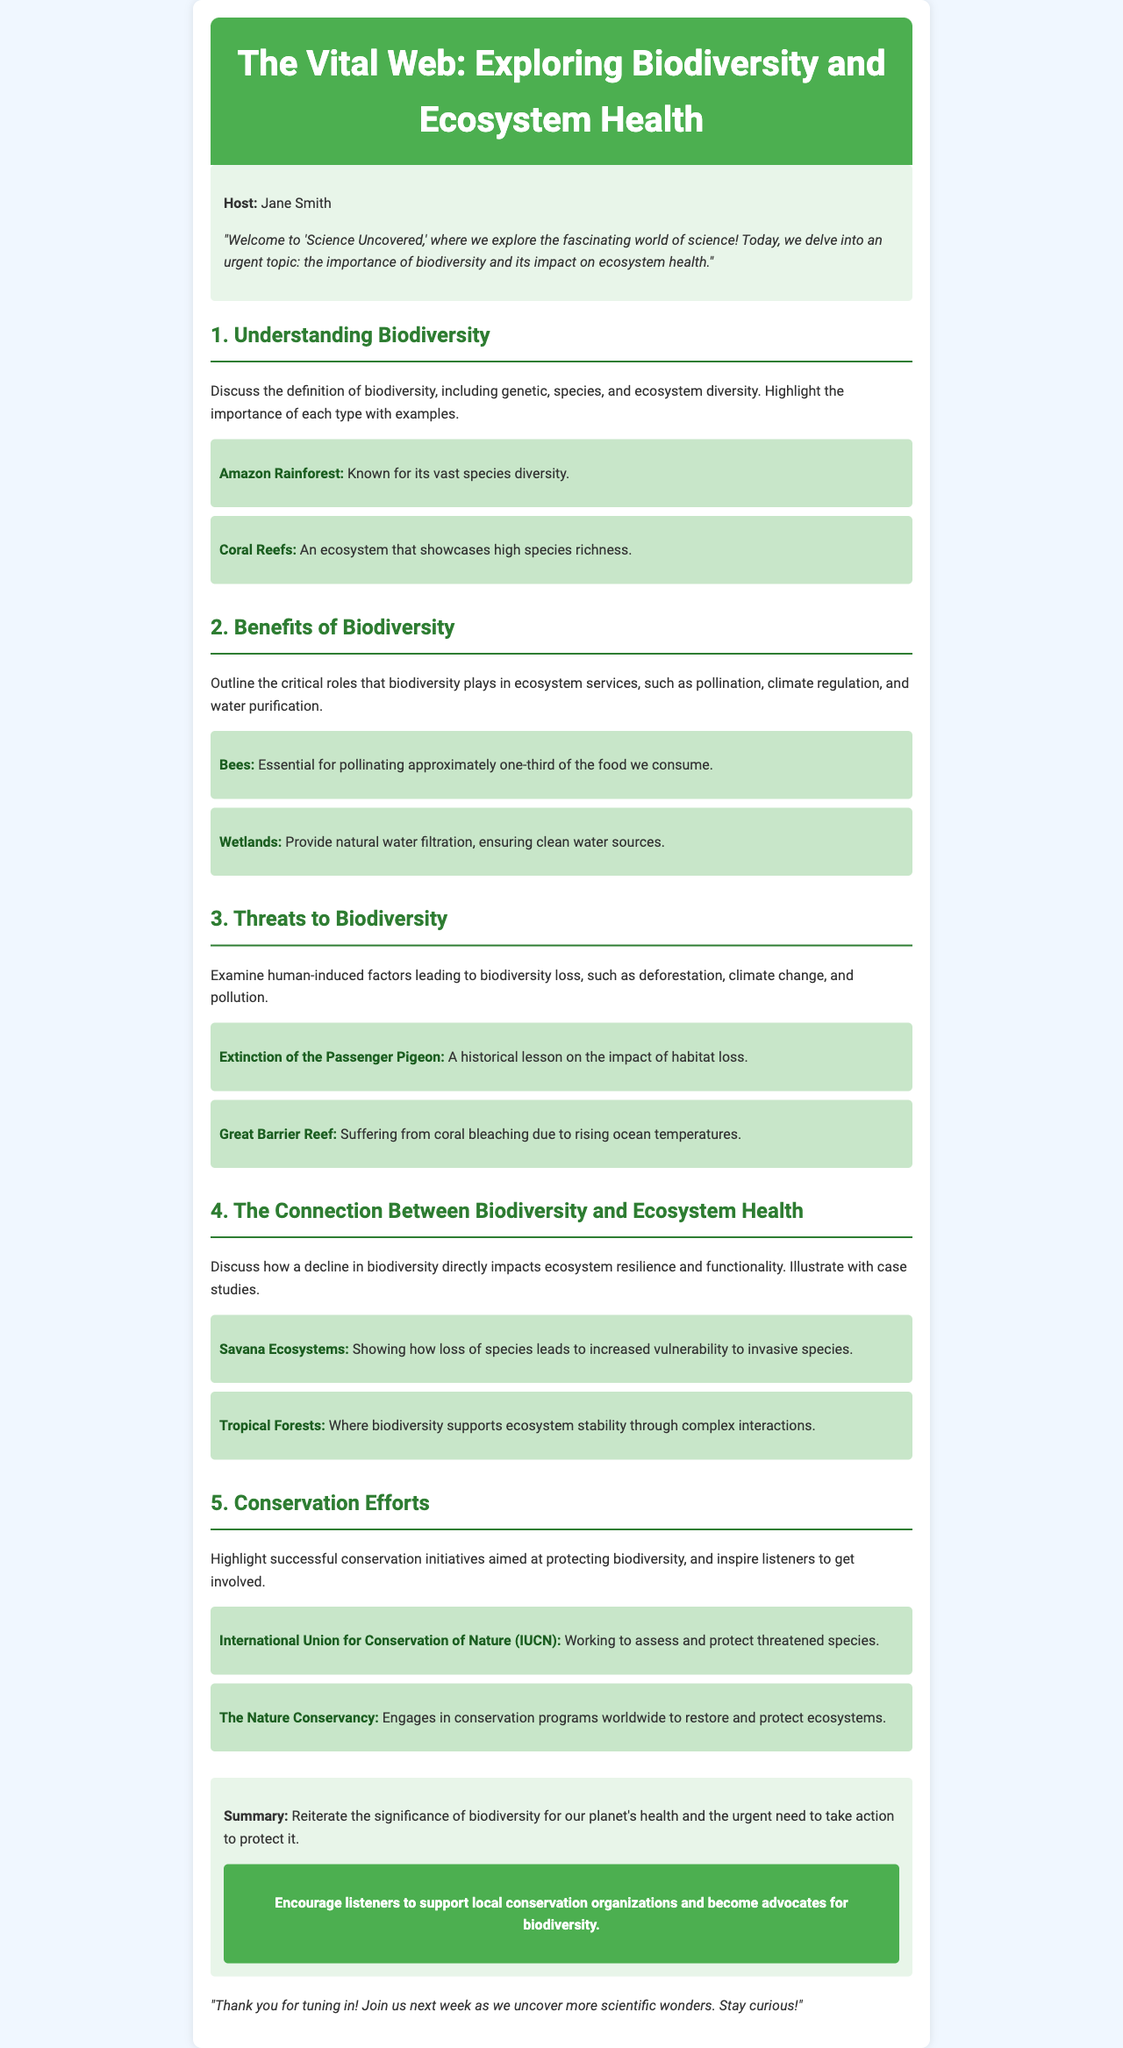What is the title of the podcast episode? The title is presented in the header of the document.
Answer: The Vital Web: Exploring Biodiversity and Ecosystem Health Who is the host of the podcast? The host's name is mentioned in the introduction section.
Answer: Jane Smith What are the three types of biodiversity discussed? The types are outlined in the first segment of the episode.
Answer: Genetic, species, and ecosystem diversity What significant role do bees play according to the podcast? The role is specified in the benefits section.
Answer: Pollinating approximately one-third of the food we consume Which historical event is cited as a lesson on habitat loss? This event is mentioned in the threats to biodiversity section.
Answer: Extinction of the Passenger Pigeon What does the document recommend listeners do to support biodiversity? The recommendation is included in the conclusion section.
Answer: Support local conservation organizations Name one conservation organization mentioned in the podcast. This information is found in the conservation efforts segment.
Answer: International Union for Conservation of Nature (IUCN) What ecosystem is highlighted for showcasing high species richness? This is specified in the first segment of the episode.
Answer: Coral Reefs Which ecosystem demonstrates increased vulnerability to invasive species? This detail is discussed in the connection segment.
Answer: Savana Ecosystems 